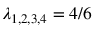Convert formula to latex. <formula><loc_0><loc_0><loc_500><loc_500>\lambda _ { 1 , 2 , 3 , 4 } = 4 / 6</formula> 